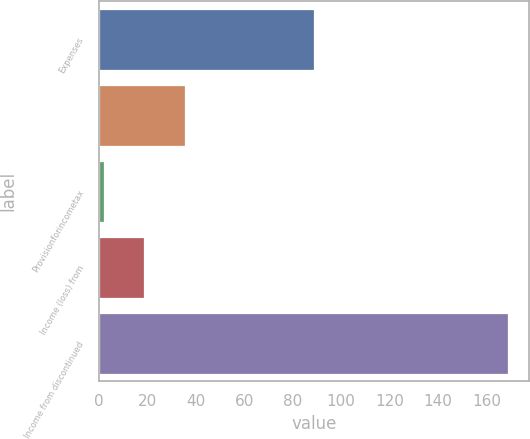Convert chart to OTSL. <chart><loc_0><loc_0><loc_500><loc_500><bar_chart><fcel>Expenses<fcel>Unnamed: 1<fcel>Provisionforincometax<fcel>Income (loss) from<fcel>Income from discontinued<nl><fcel>89<fcel>35.4<fcel>2<fcel>18.7<fcel>169<nl></chart> 